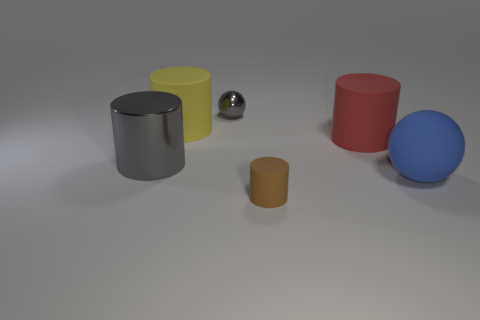Subtract all large yellow matte cylinders. How many cylinders are left? 3 Add 3 blue things. How many objects exist? 9 Subtract 2 cylinders. How many cylinders are left? 2 Subtract all brown cylinders. How many cylinders are left? 3 Add 1 rubber cylinders. How many rubber cylinders are left? 4 Add 1 yellow rubber things. How many yellow rubber things exist? 2 Subtract 1 brown cylinders. How many objects are left? 5 Subtract all spheres. How many objects are left? 4 Subtract all red cylinders. Subtract all brown balls. How many cylinders are left? 3 Subtract all metallic cylinders. Subtract all big yellow cylinders. How many objects are left? 4 